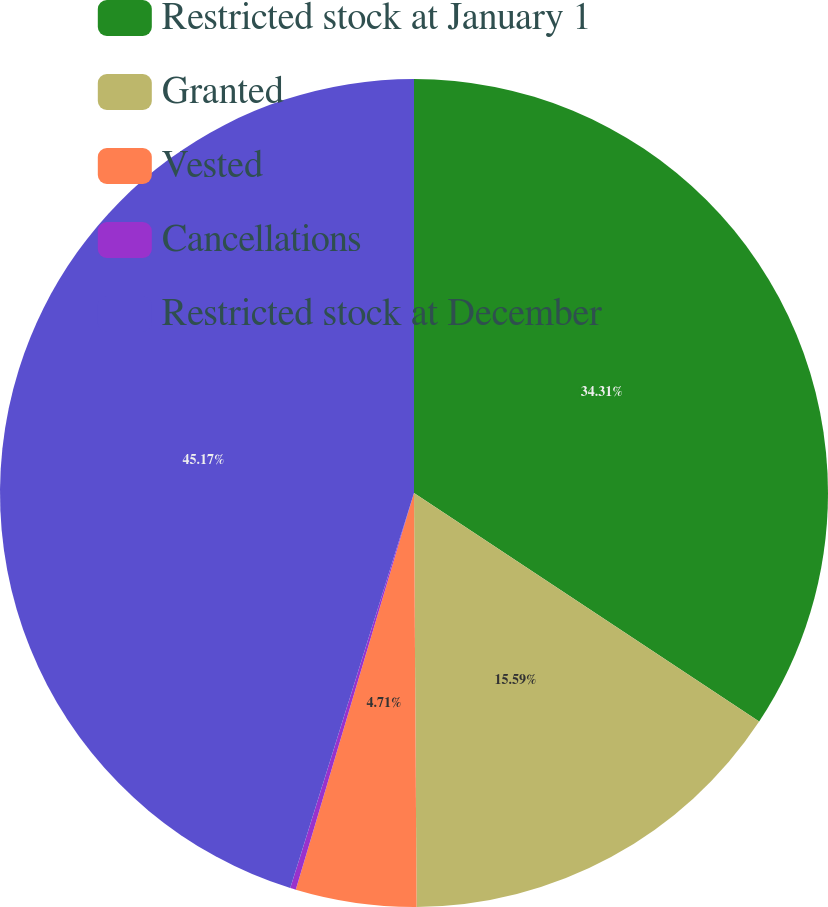<chart> <loc_0><loc_0><loc_500><loc_500><pie_chart><fcel>Restricted stock at January 1<fcel>Granted<fcel>Vested<fcel>Cancellations<fcel>Restricted stock at December<nl><fcel>34.31%<fcel>15.59%<fcel>4.71%<fcel>0.22%<fcel>45.17%<nl></chart> 